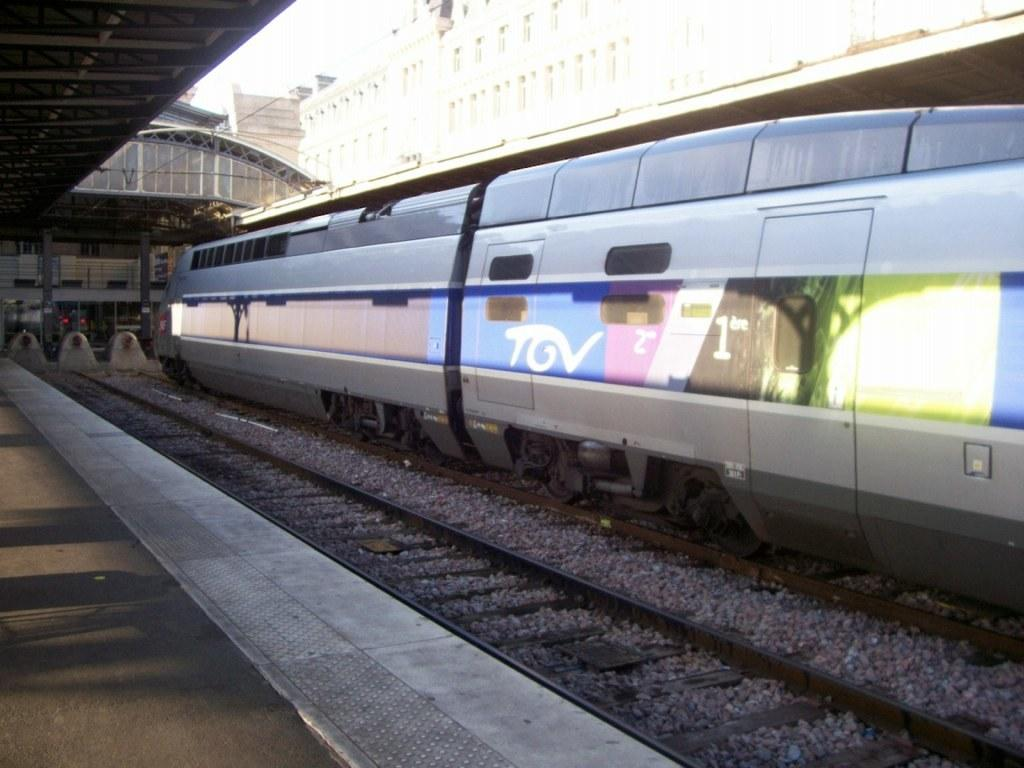Provide a one-sentence caption for the provided image. The train at the station has the lettering TGV on the side of it. 